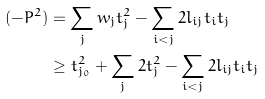Convert formula to latex. <formula><loc_0><loc_0><loc_500><loc_500>( - P ^ { 2 } ) & = \sum _ { j } w _ { j } t _ { j } ^ { 2 } - \sum _ { i < j } 2 l _ { i j } t _ { i } t _ { j } \\ & \geq t _ { j _ { 0 } } ^ { 2 } + \sum _ { j } 2 t _ { j } ^ { 2 } - \sum _ { i < j } 2 l _ { i j } t _ { i } t _ { j }</formula> 